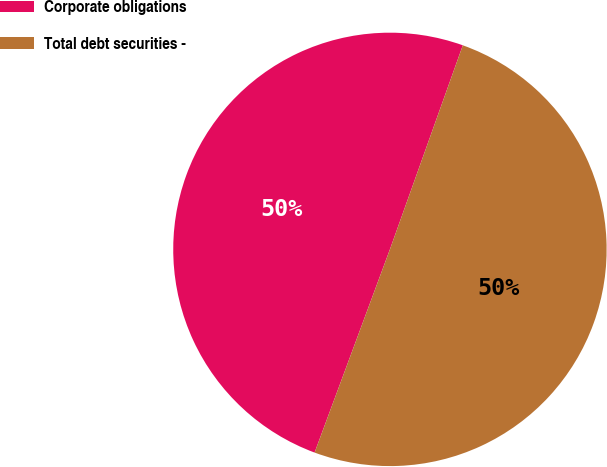<chart> <loc_0><loc_0><loc_500><loc_500><pie_chart><fcel>Corporate obligations<fcel>Total debt securities -<nl><fcel>49.81%<fcel>50.19%<nl></chart> 